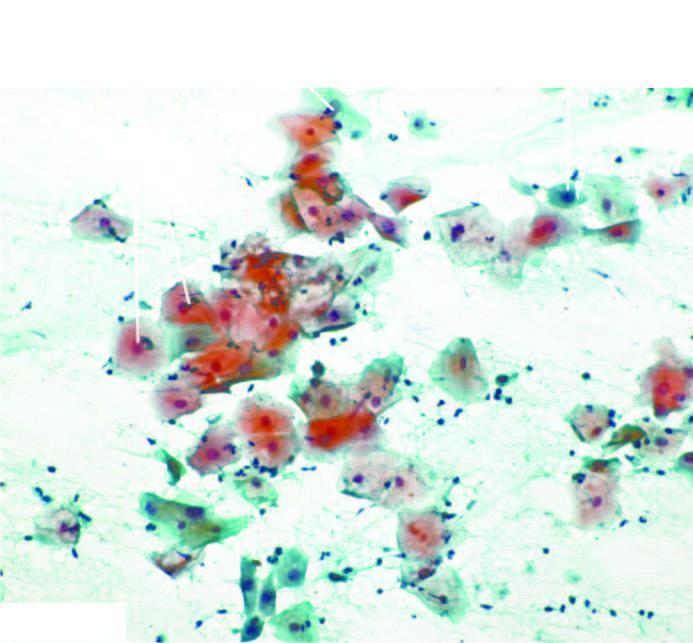what is seen in normal pap smear?
Answer the question using a single word or phrase. Various types of epithelial cells 